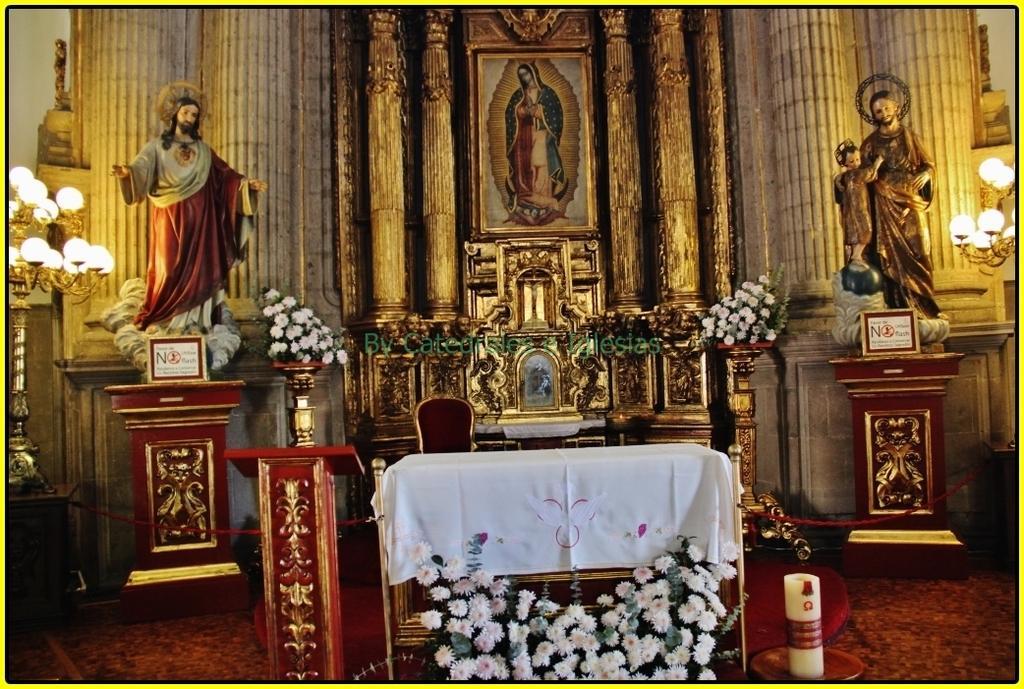Can you describe this image briefly? This picture describes about inside view of a church, in this we can find statues, lights, flowers and frames. 